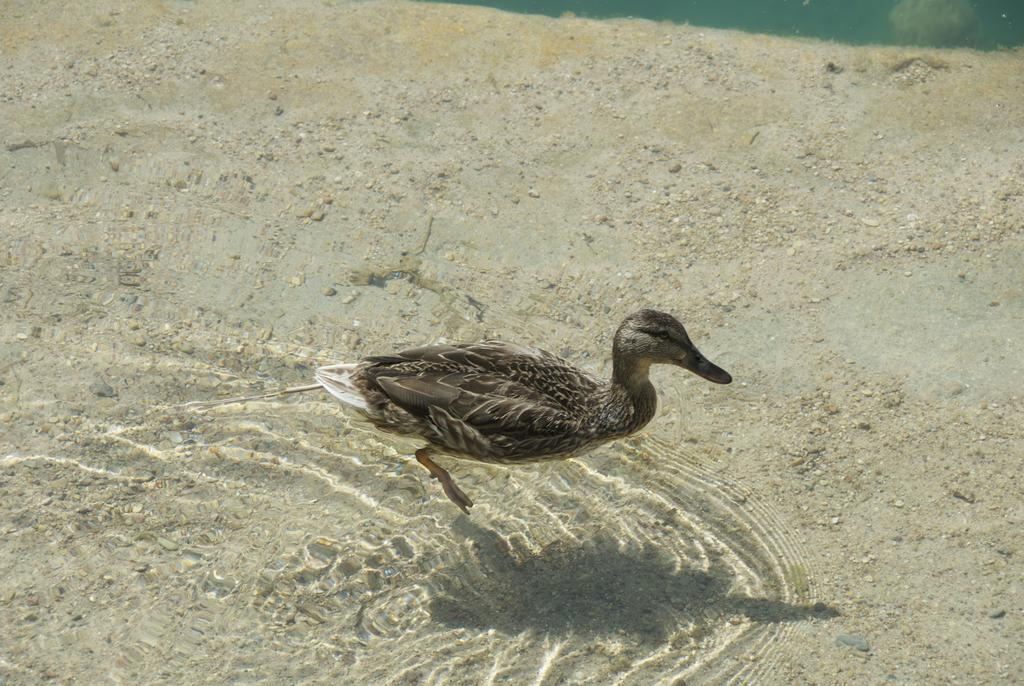What type of animal is in the image? There is a duck in the image. What is the texture of the water in the image? There is sand in the water in the image. How many questions are visible in the image? There are no questions visible in the image. Are there any cows present in the image? There are no cows present in the image. 